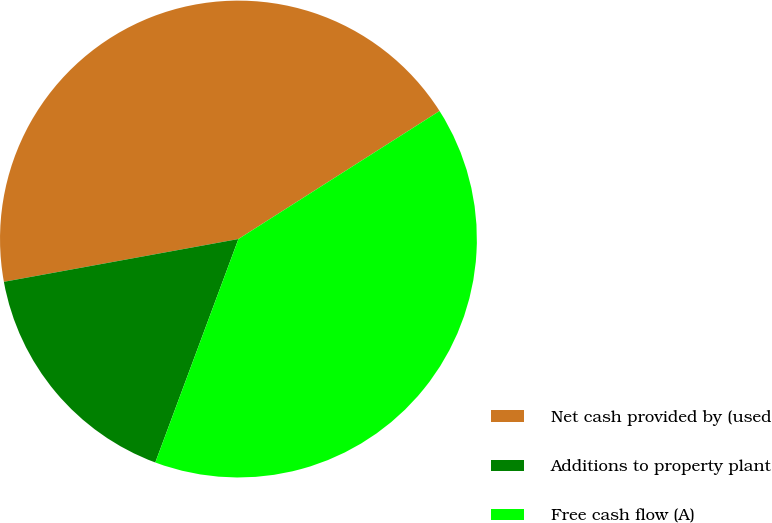<chart> <loc_0><loc_0><loc_500><loc_500><pie_chart><fcel>Net cash provided by (used<fcel>Additions to property plant<fcel>Free cash flow (A)<nl><fcel>43.85%<fcel>16.46%<fcel>39.69%<nl></chart> 